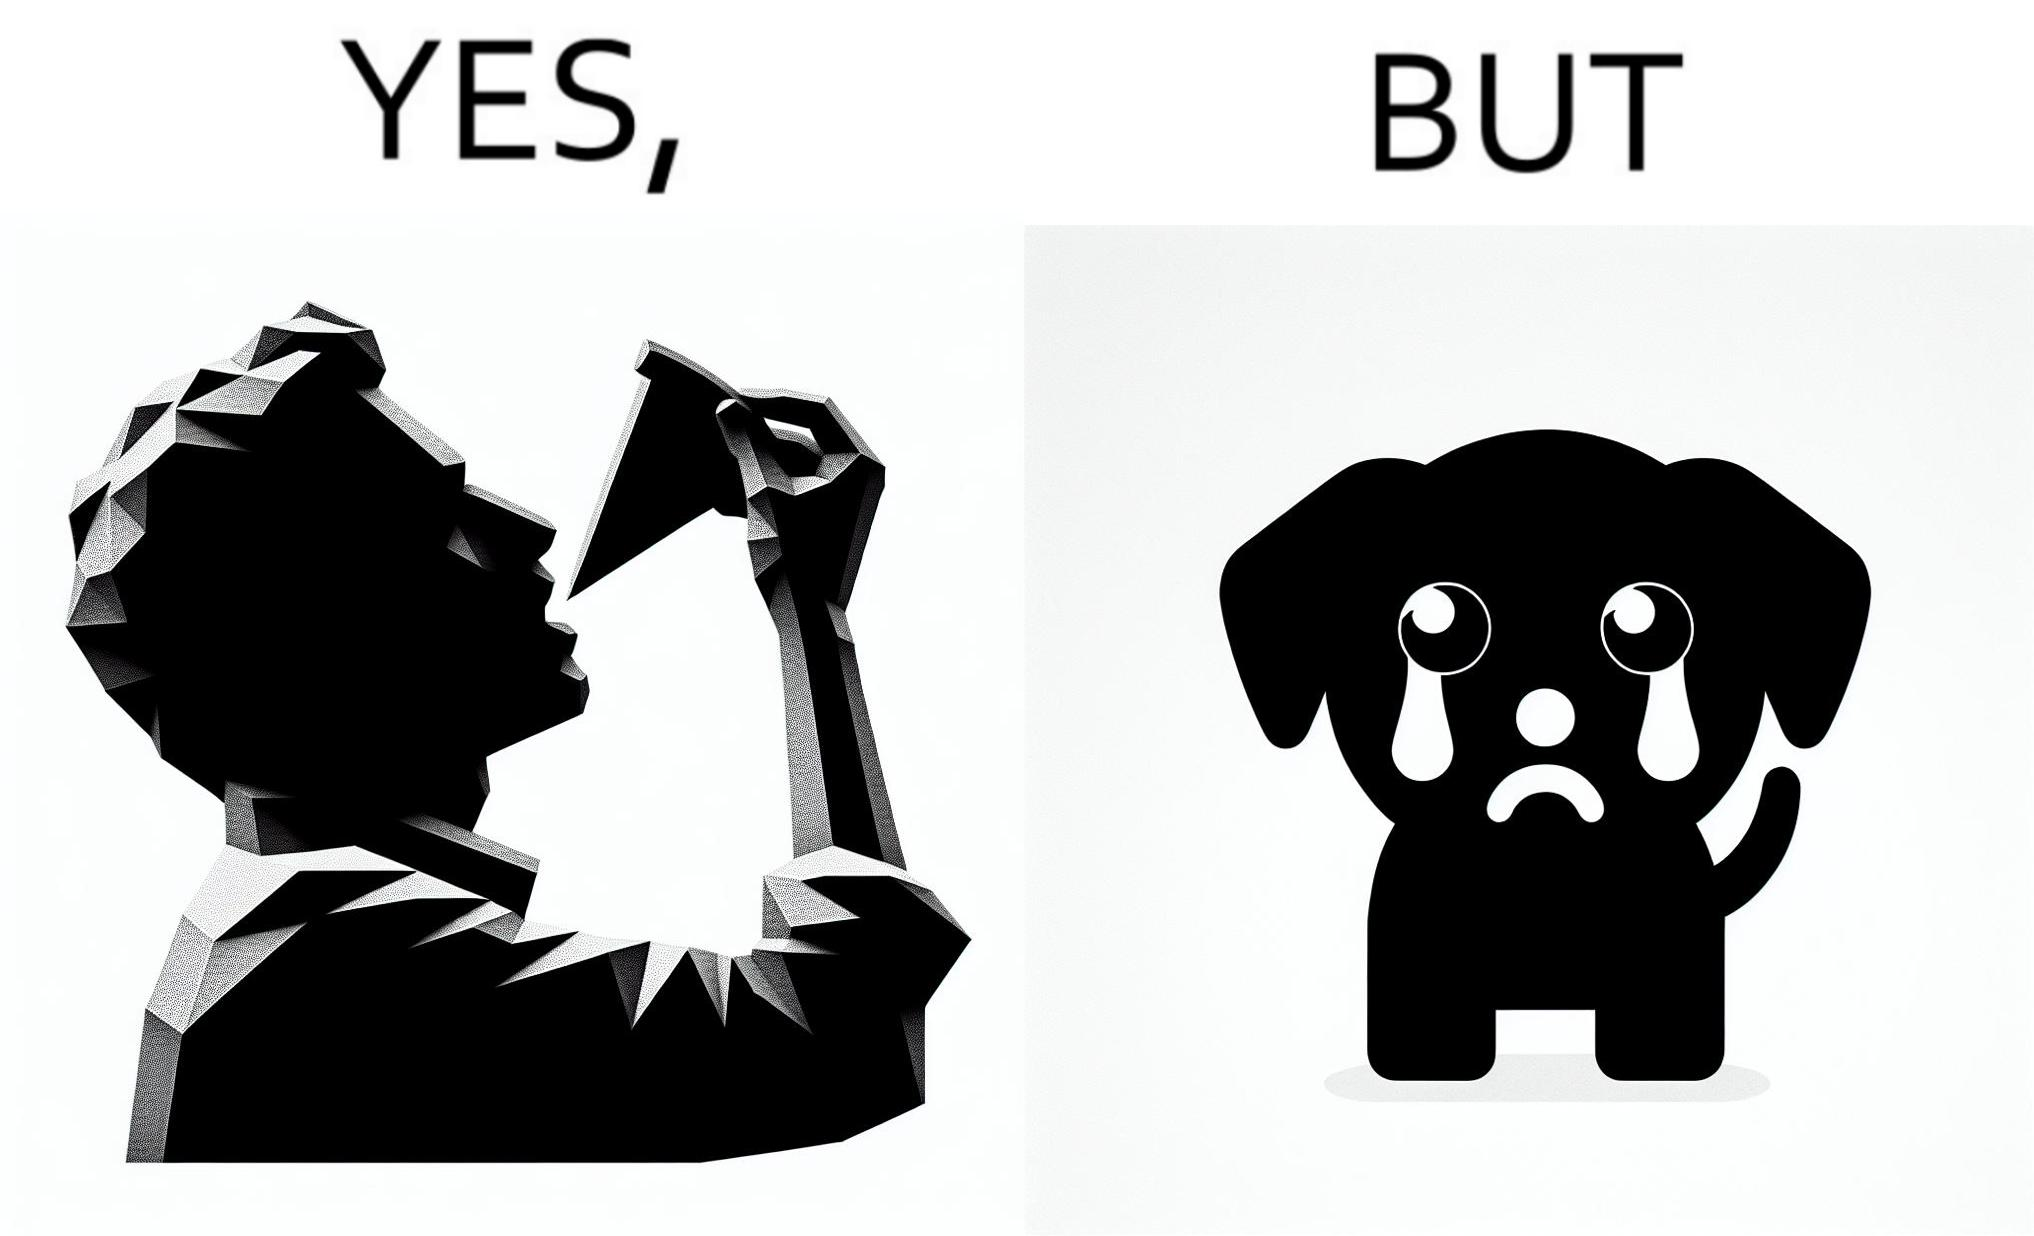Explain the humor or irony in this image. The images are funny since they show how pet owners cannot enjoy any tasty food like pizza without sharing with their pets. The look from the pets makes the owner too guilty if he does not share his food 